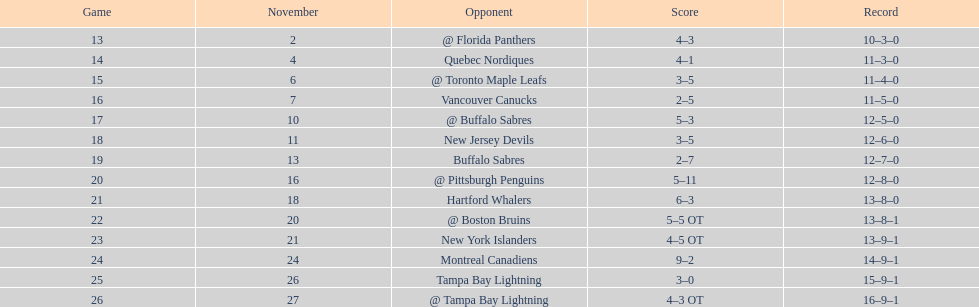What was the total penalty minutes that dave brown had on the 1993-1994 flyers? 137. 